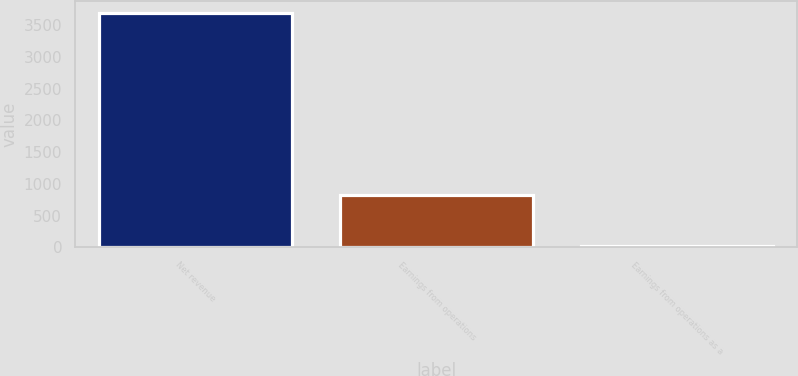Convert chart. <chart><loc_0><loc_0><loc_500><loc_500><bar_chart><fcel>Net revenue<fcel>Earnings from operations<fcel>Earnings from operations as a<nl><fcel>3701<fcel>828<fcel>22.4<nl></chart> 